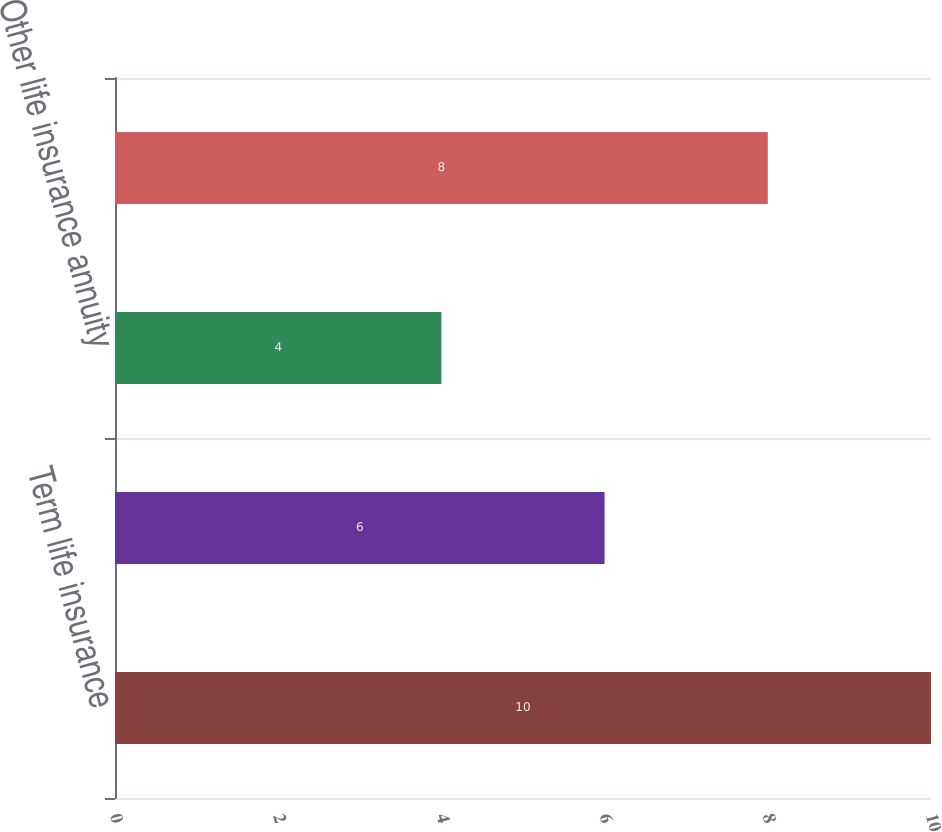<chart> <loc_0><loc_0><loc_500><loc_500><bar_chart><fcel>Term life insurance<fcel>Universal life insurance<fcel>Other life insurance annuity<fcel>Net earned premiums<nl><fcel>10<fcel>6<fcel>4<fcel>8<nl></chart> 